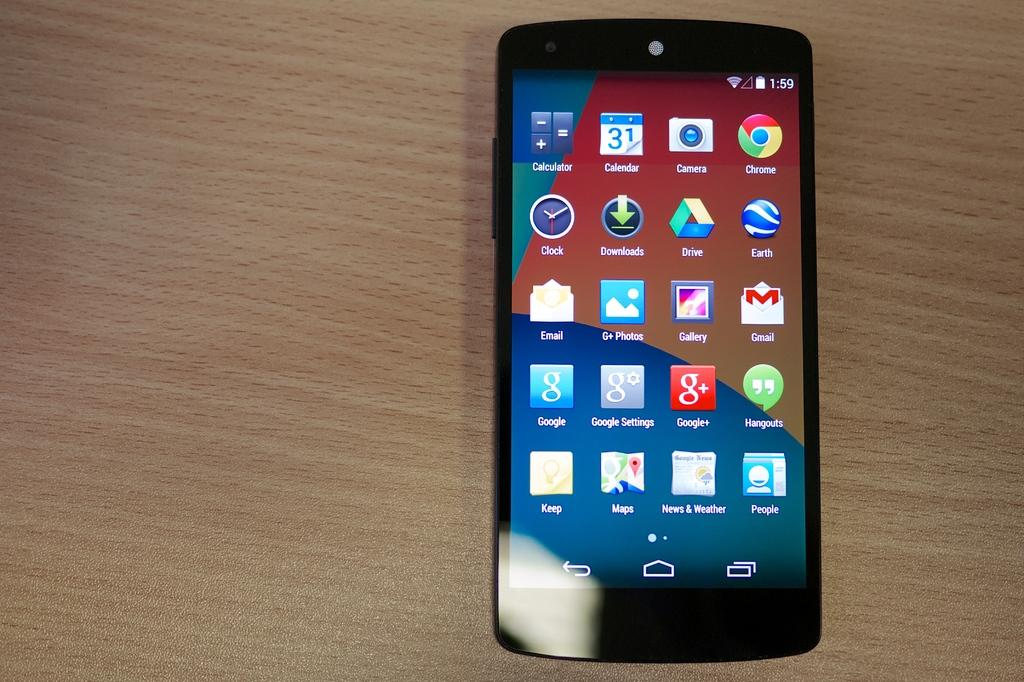Provide a one-sentence caption for the provided image. A smart phone home screen shows several apps including Chrome, and other Google Apps. 